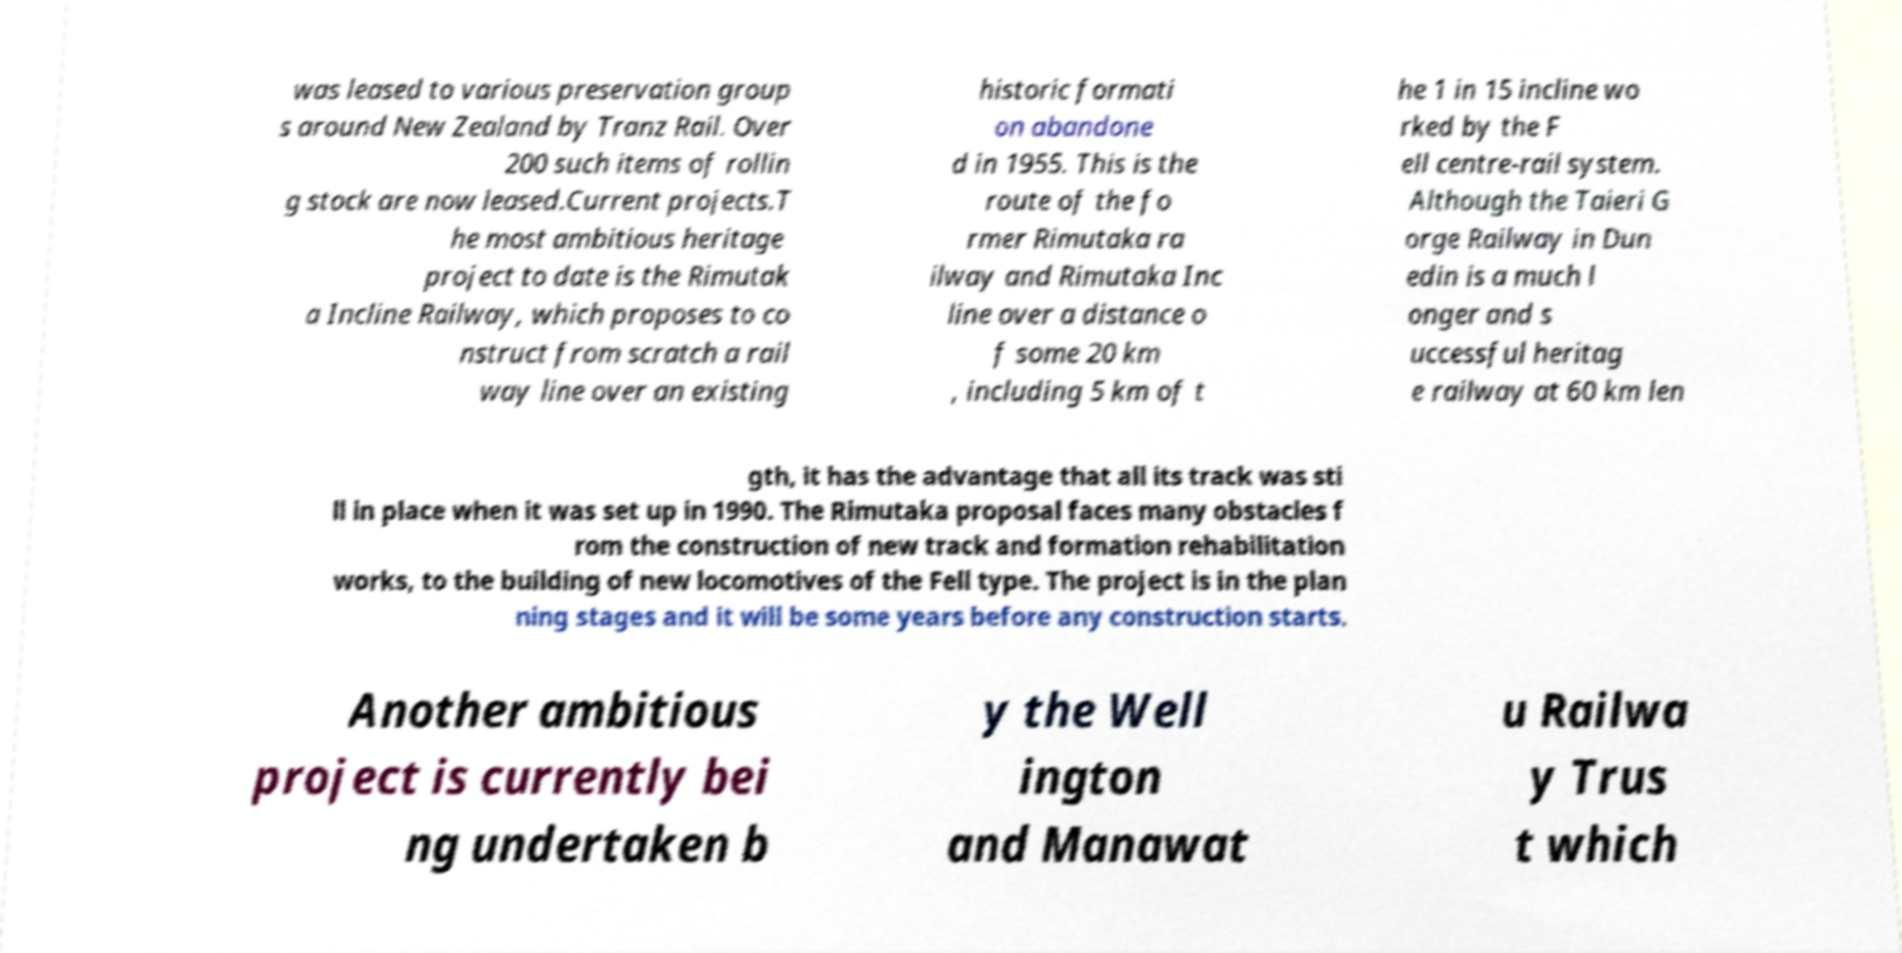For documentation purposes, I need the text within this image transcribed. Could you provide that? was leased to various preservation group s around New Zealand by Tranz Rail. Over 200 such items of rollin g stock are now leased.Current projects.T he most ambitious heritage project to date is the Rimutak a Incline Railway, which proposes to co nstruct from scratch a rail way line over an existing historic formati on abandone d in 1955. This is the route of the fo rmer Rimutaka ra ilway and Rimutaka Inc line over a distance o f some 20 km , including 5 km of t he 1 in 15 incline wo rked by the F ell centre-rail system. Although the Taieri G orge Railway in Dun edin is a much l onger and s uccessful heritag e railway at 60 km len gth, it has the advantage that all its track was sti ll in place when it was set up in 1990. The Rimutaka proposal faces many obstacles f rom the construction of new track and formation rehabilitation works, to the building of new locomotives of the Fell type. The project is in the plan ning stages and it will be some years before any construction starts. Another ambitious project is currently bei ng undertaken b y the Well ington and Manawat u Railwa y Trus t which 